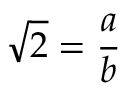Convert formula to latex. <formula><loc_0><loc_0><loc_500><loc_500>{ \sqrt { 2 } } = { \frac { a } { b } }</formula> 